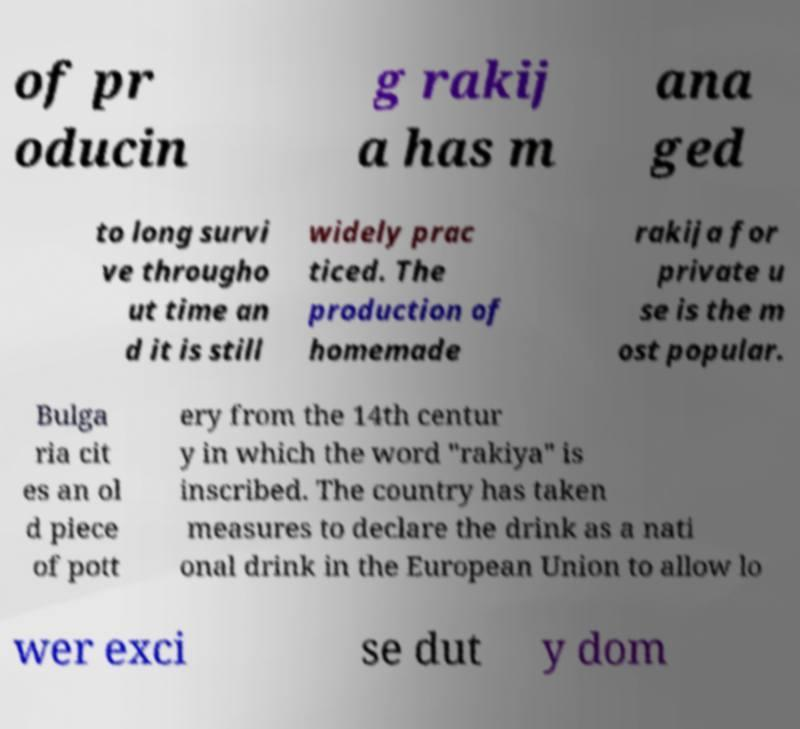Can you accurately transcribe the text from the provided image for me? of pr oducin g rakij a has m ana ged to long survi ve througho ut time an d it is still widely prac ticed. The production of homemade rakija for private u se is the m ost popular. Bulga ria cit es an ol d piece of pott ery from the 14th centur y in which the word "rakiya" is inscribed. The country has taken measures to declare the drink as a nati onal drink in the European Union to allow lo wer exci se dut y dom 